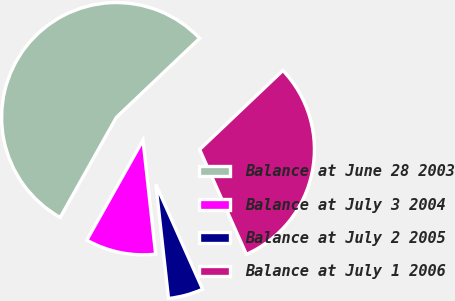Convert chart to OTSL. <chart><loc_0><loc_0><loc_500><loc_500><pie_chart><fcel>Balance at June 28 2003<fcel>Balance at July 3 2004<fcel>Balance at July 2 2005<fcel>Balance at July 1 2006<nl><fcel>54.77%<fcel>9.9%<fcel>4.92%<fcel>30.41%<nl></chart> 